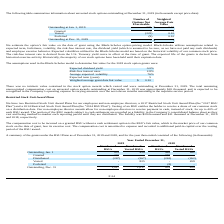According to Acura Pharmaceuticals's financial document, What are the two restricted stock unit award plans for employee and non-employee directors? We have two Restricted Stock Unit Award Plans for our employees and non-employee directors, a 2017 Restricted Stock Unit Award Plan (the “2017 RSU Plan”) and a 2014 Restricted Stock Unit Award Plan (the “2014 RSU Plan”).. The document states: "service period. Restricted Stock Unit Award Plans We have two Restricted Stock Unit Award Plans for our employees and non-employee directors, a 2017 R..." Also, What was the RSU liability for non-employee directors in 2019 and 2018? The liability was $29 thousand and $11 thousand at December 31, 2019 and 2018, respectively.. The document states: "each reporting period until they are distributed. The liability was $29 thousand and $11 thousand at December 31, 2019 and 2018, respectively. The com..." Also, What is the ending outstanding number of vested RSUs in 2019? According to the financial document, 1,017 (in thousands). The relevant text states: "Outstanding, Dec. 31 1,017 1,017 951 459..." Also, can you calculate: What is the difference between ending outstanding balance of RSUs and Vested RSUs in 2018? Based on the calculation: 951 - 459 , the result is 492 (in thousands). This is based on the information: "Outstanding, Jan. 1 951 459 462 262 Outstanding, Jan. 1 951 459 462 262..." The key data points involved are: 459, 951. Also, can you calculate: What is the difference between the number of RSUs granted in 2019 and 2018? Based on the calculation: 759 - 333 , the result is 426 (in thousands). This is based on the information: "Granted 333 - 759 - Granted 333 - 759 -..." The key data points involved are: 333, 759. Also, can you calculate: What is the percentage increase in number of RSUs from 2018 to 2019? To answer this question, I need to perform calculations using the financial data. The calculation is: (1,017 - 951) / 951 , which equals 6.94 (percentage). This is based on the information: "Outstanding, Dec. 31 1,017 1,017 951 459 Outstanding, Dec. 31 1,017 1,017 951 459..." The key data points involved are: 1,017, 951. 